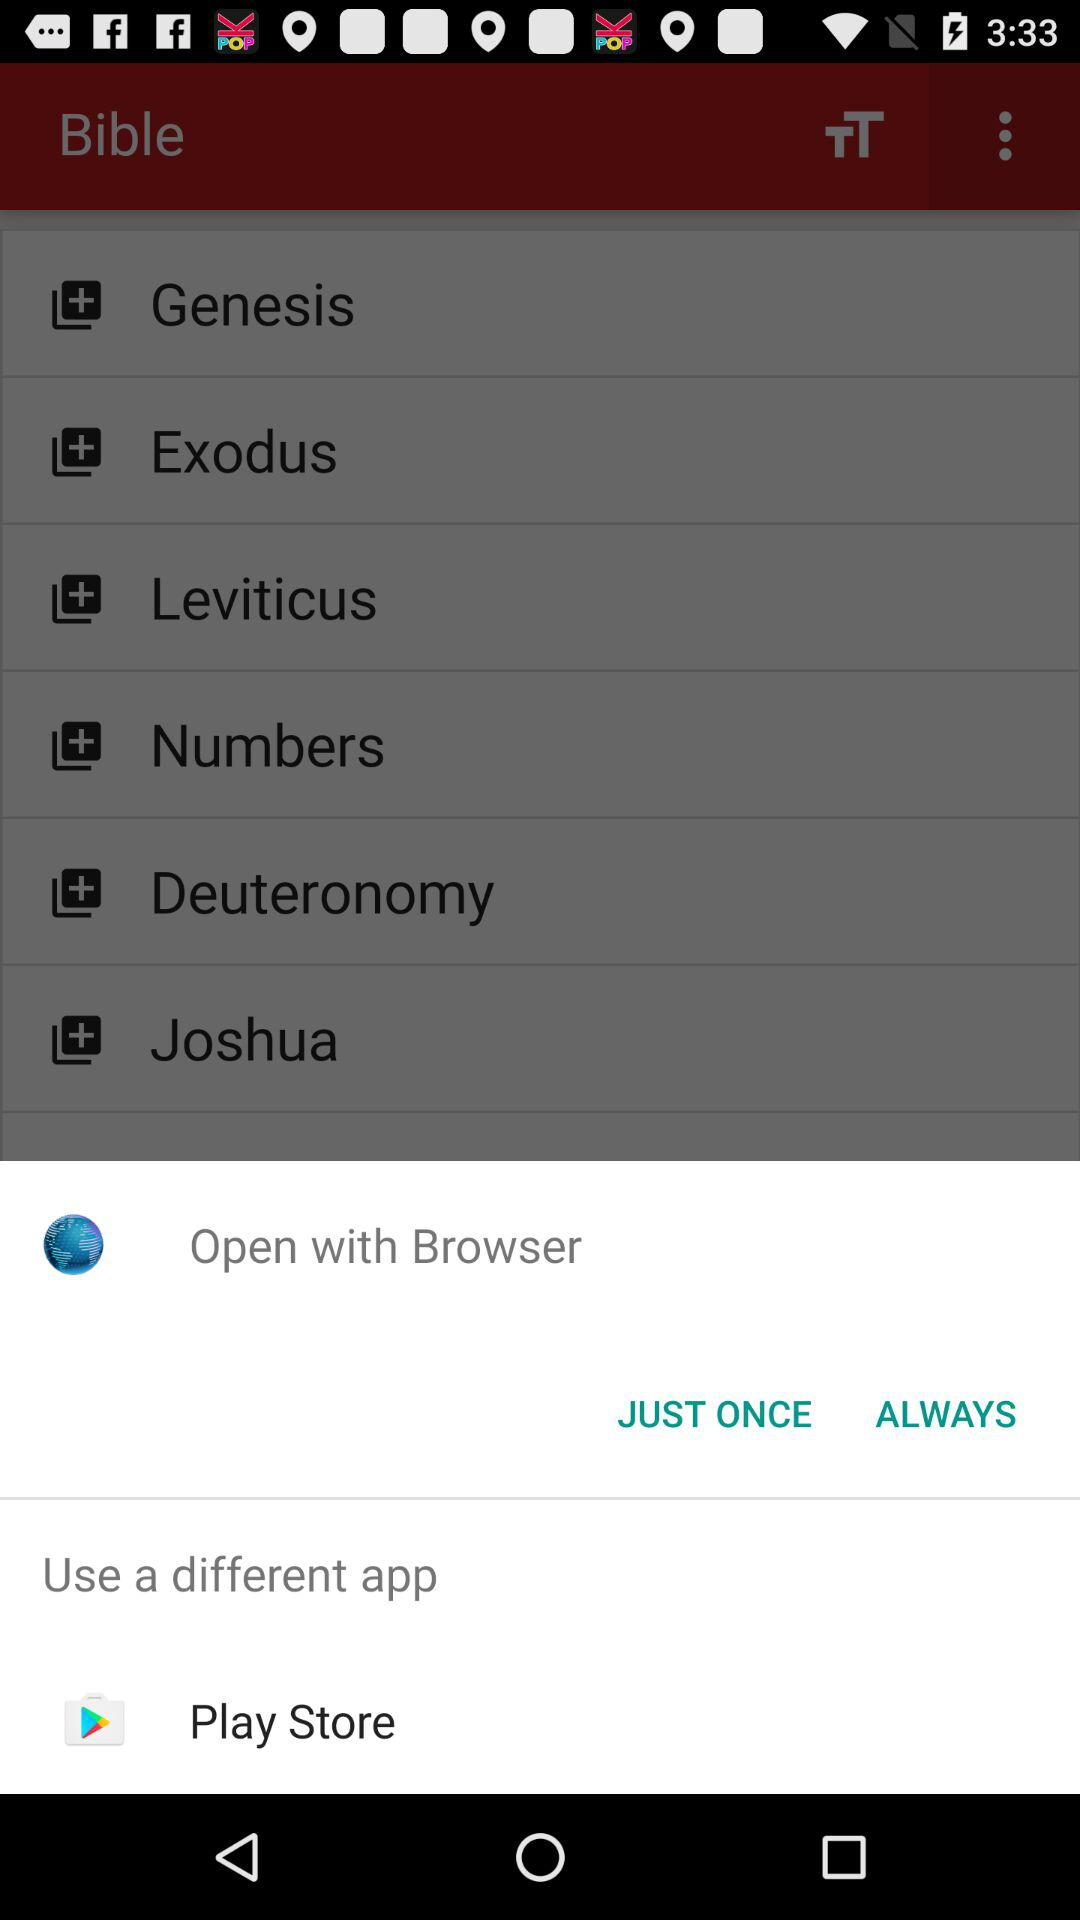What different applications can we use to open it? The application is "Play Store". 